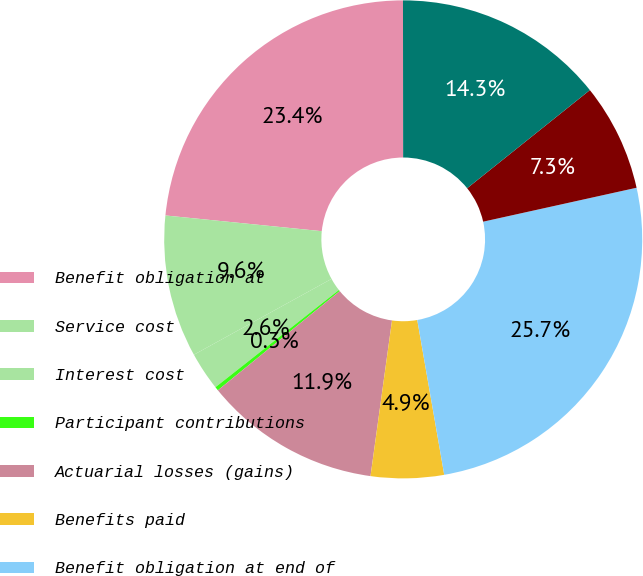<chart> <loc_0><loc_0><loc_500><loc_500><pie_chart><fcel>Benefit obligation at<fcel>Service cost<fcel>Interest cost<fcel>Participant contributions<fcel>Actuarial losses (gains)<fcel>Benefits paid<fcel>Benefit obligation at end of<fcel>Employer contributions<fcel>Funded status at end of year<nl><fcel>23.39%<fcel>9.61%<fcel>2.6%<fcel>0.26%<fcel>11.94%<fcel>4.93%<fcel>25.72%<fcel>7.27%<fcel>14.28%<nl></chart> 